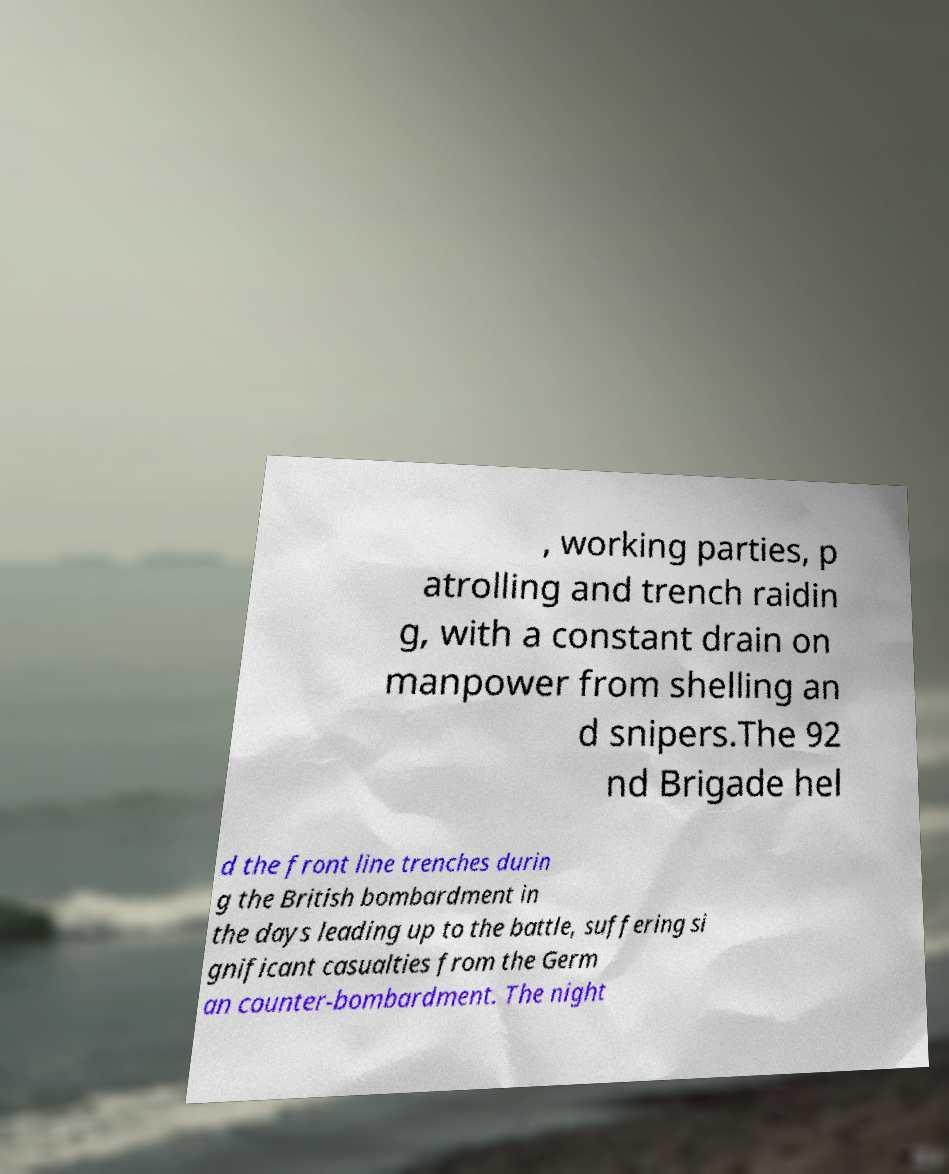Can you accurately transcribe the text from the provided image for me? , working parties, p atrolling and trench raidin g, with a constant drain on manpower from shelling an d snipers.The 92 nd Brigade hel d the front line trenches durin g the British bombardment in the days leading up to the battle, suffering si gnificant casualties from the Germ an counter-bombardment. The night 